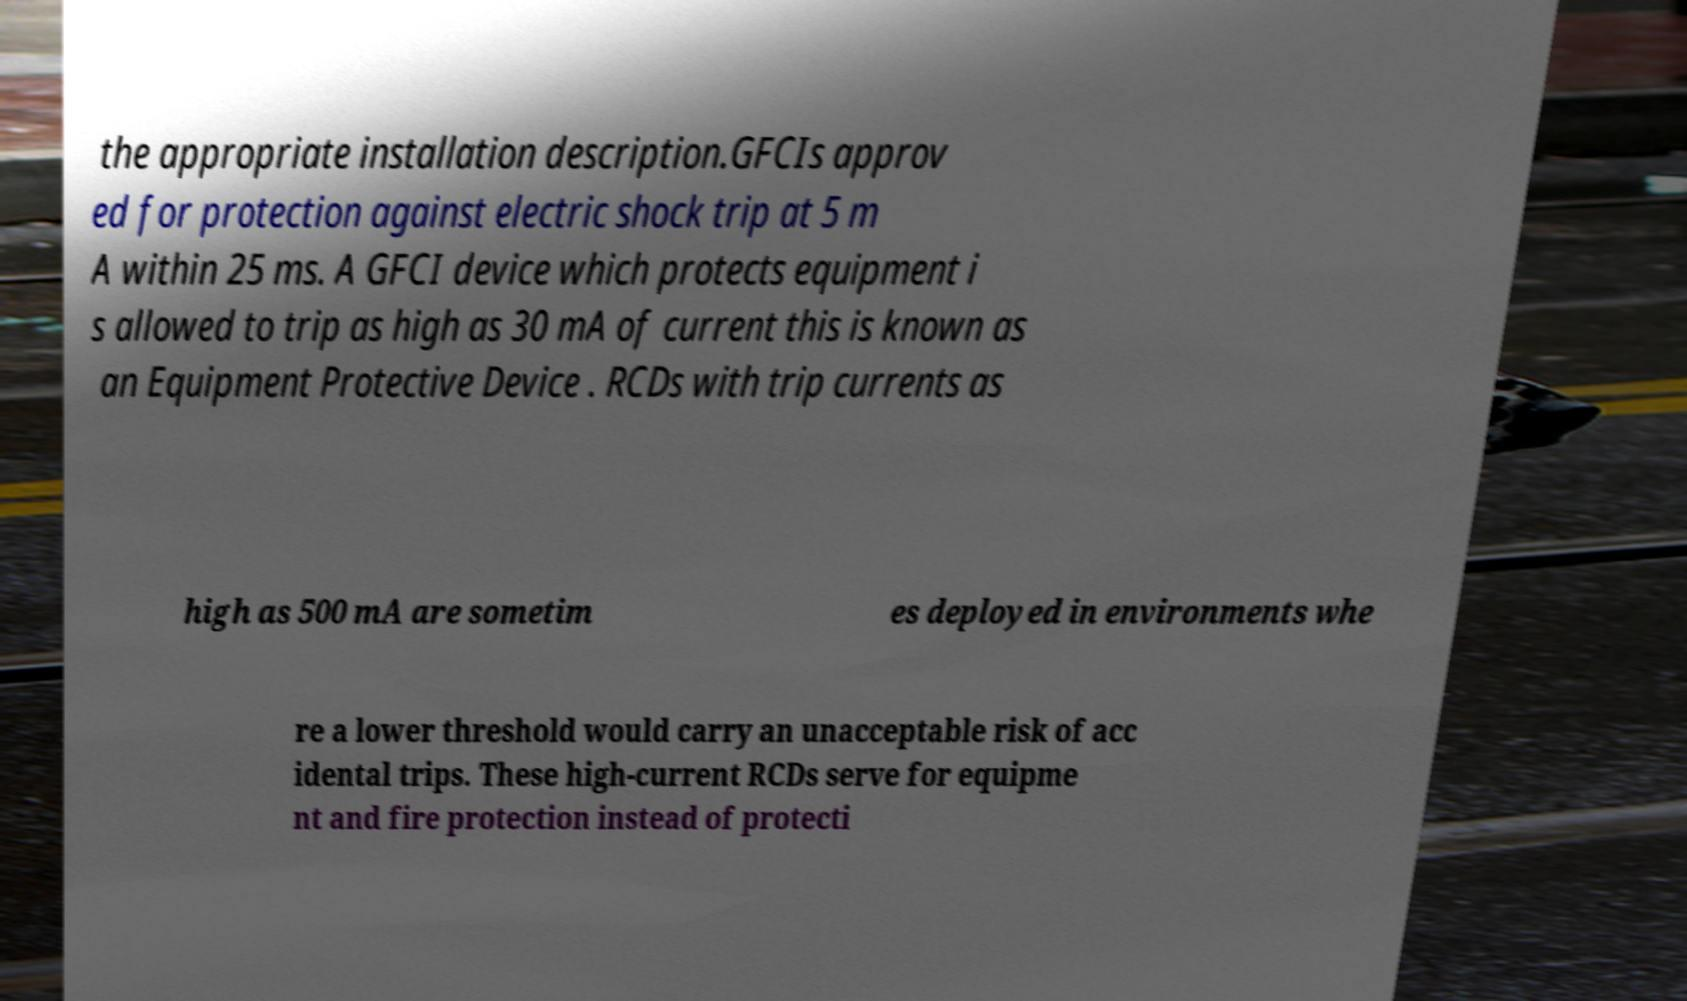Can you read and provide the text displayed in the image?This photo seems to have some interesting text. Can you extract and type it out for me? the appropriate installation description.GFCIs approv ed for protection against electric shock trip at 5 m A within 25 ms. A GFCI device which protects equipment i s allowed to trip as high as 30 mA of current this is known as an Equipment Protective Device . RCDs with trip currents as high as 500 mA are sometim es deployed in environments whe re a lower threshold would carry an unacceptable risk of acc idental trips. These high-current RCDs serve for equipme nt and fire protection instead of protecti 